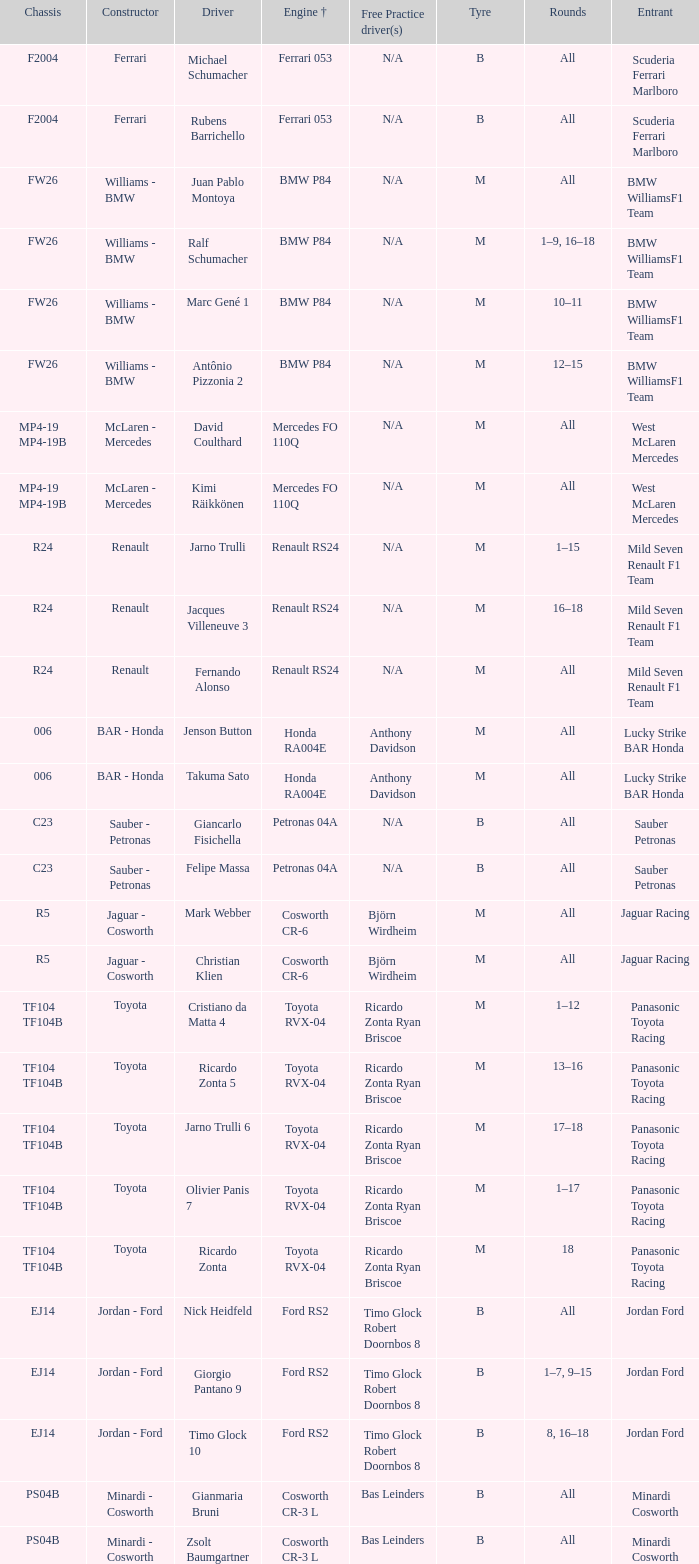What kind of free practice is there with a Ford RS2 engine +? Timo Glock Robert Doornbos 8, Timo Glock Robert Doornbos 8, Timo Glock Robert Doornbos 8. 